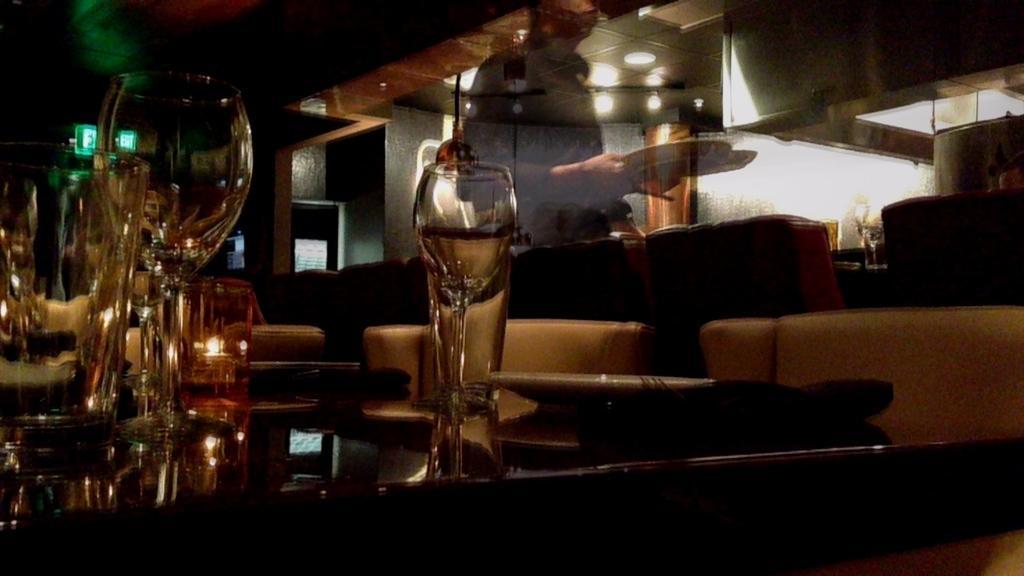Please provide a concise description of this image. In the foreground of the picture there is a table, on the table there are glasses and jars and a candle. In the background of the picture there are couches and pillows. On the top there is a glass, through the glass a person holding plates can be seen. 